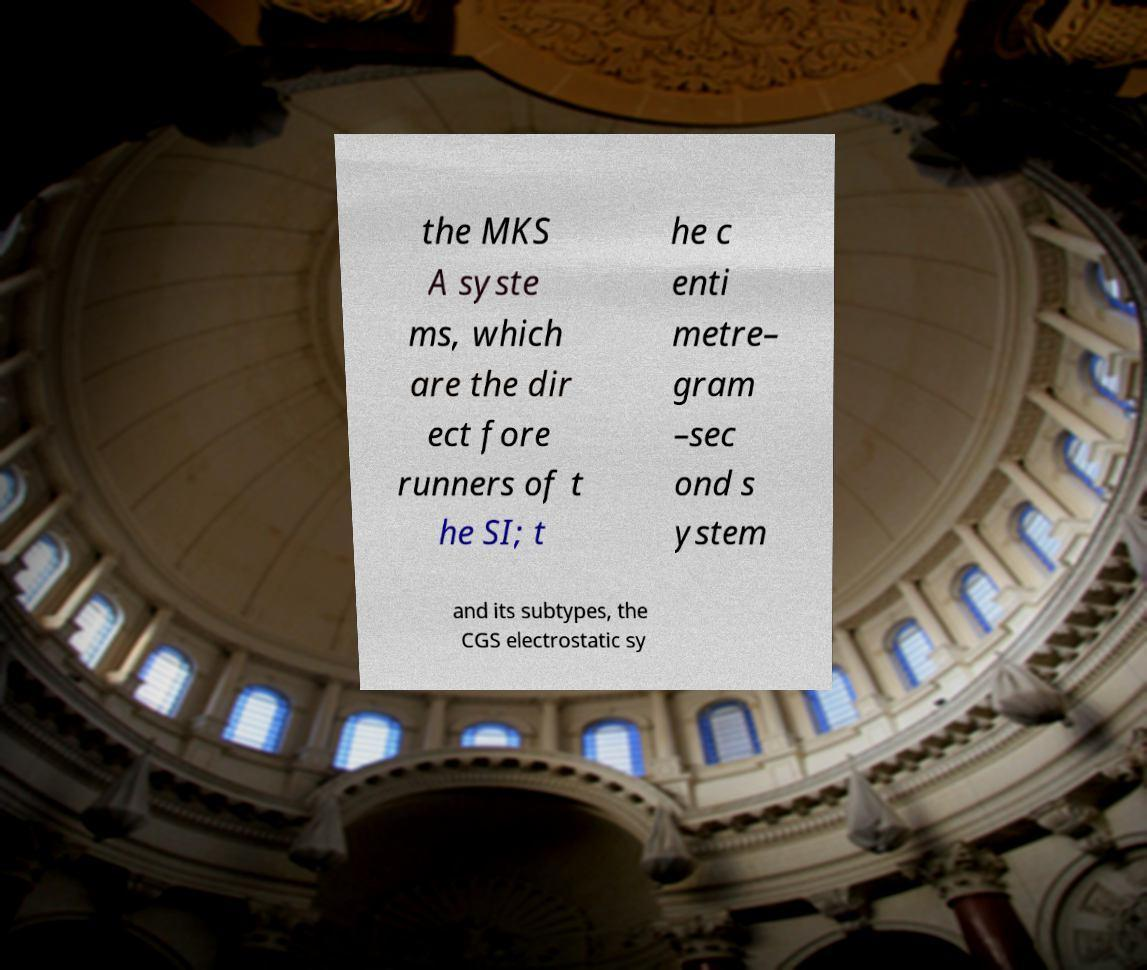What messages or text are displayed in this image? I need them in a readable, typed format. the MKS A syste ms, which are the dir ect fore runners of t he SI; t he c enti metre– gram –sec ond s ystem and its subtypes, the CGS electrostatic sy 